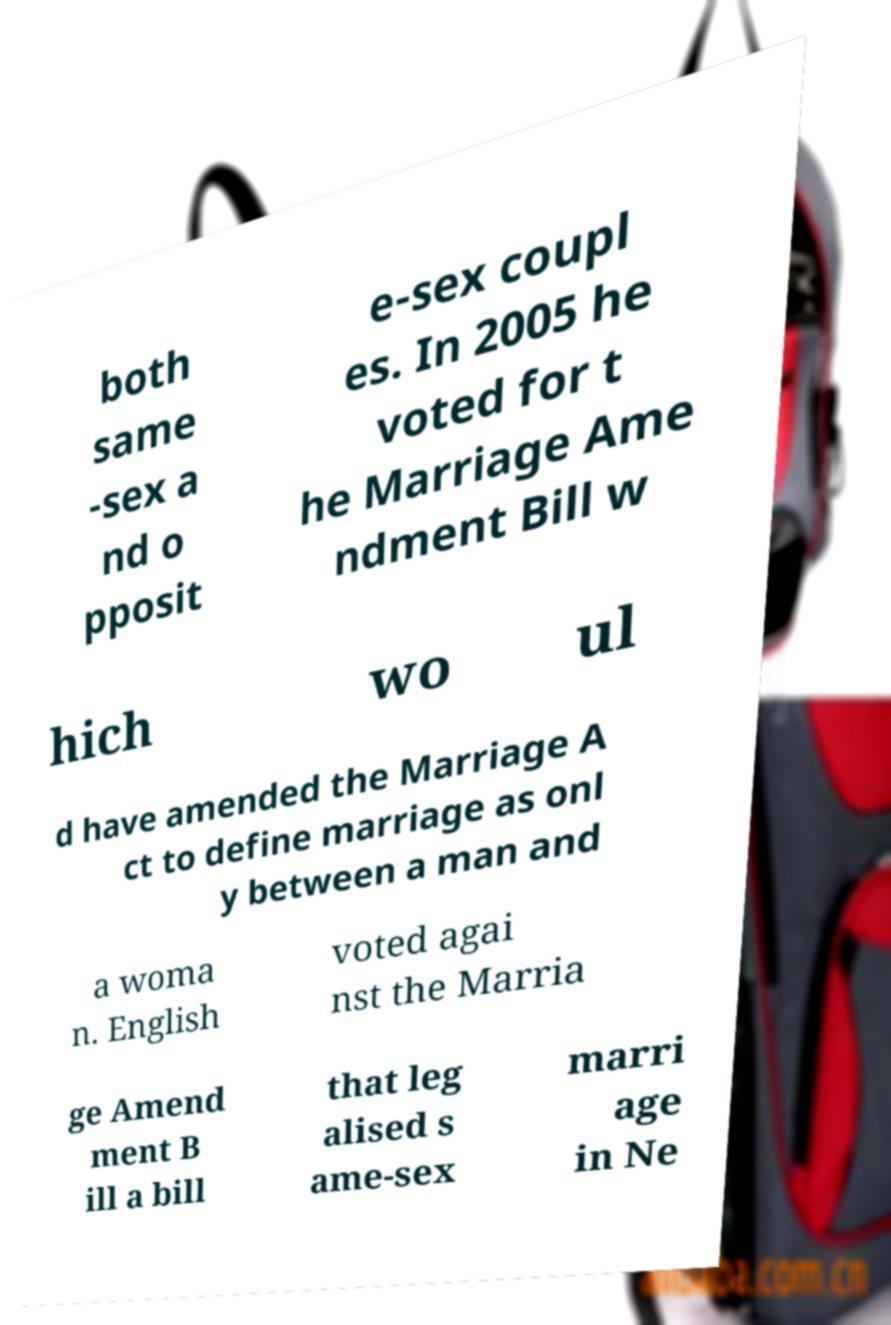I need the written content from this picture converted into text. Can you do that? both same -sex a nd o pposit e-sex coupl es. In 2005 he voted for t he Marriage Ame ndment Bill w hich wo ul d have amended the Marriage A ct to define marriage as onl y between a man and a woma n. English voted agai nst the Marria ge Amend ment B ill a bill that leg alised s ame-sex marri age in Ne 